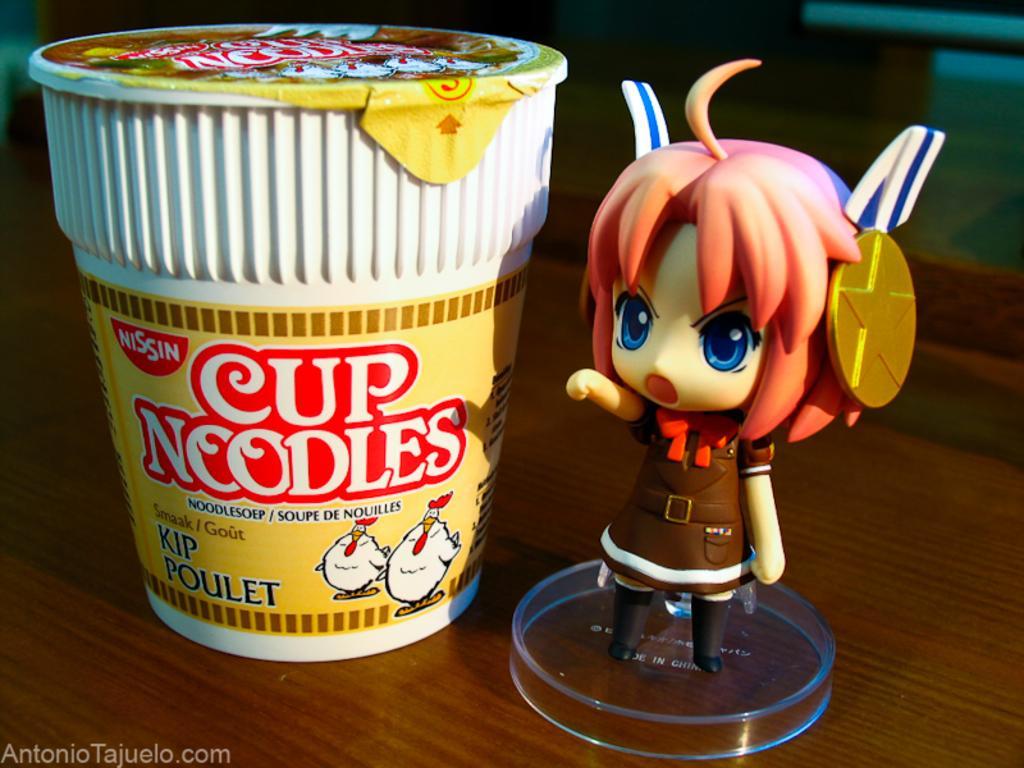How would you summarize this image in a sentence or two? As we can see in the image there is a table. On table there are cup noodles and toy. 